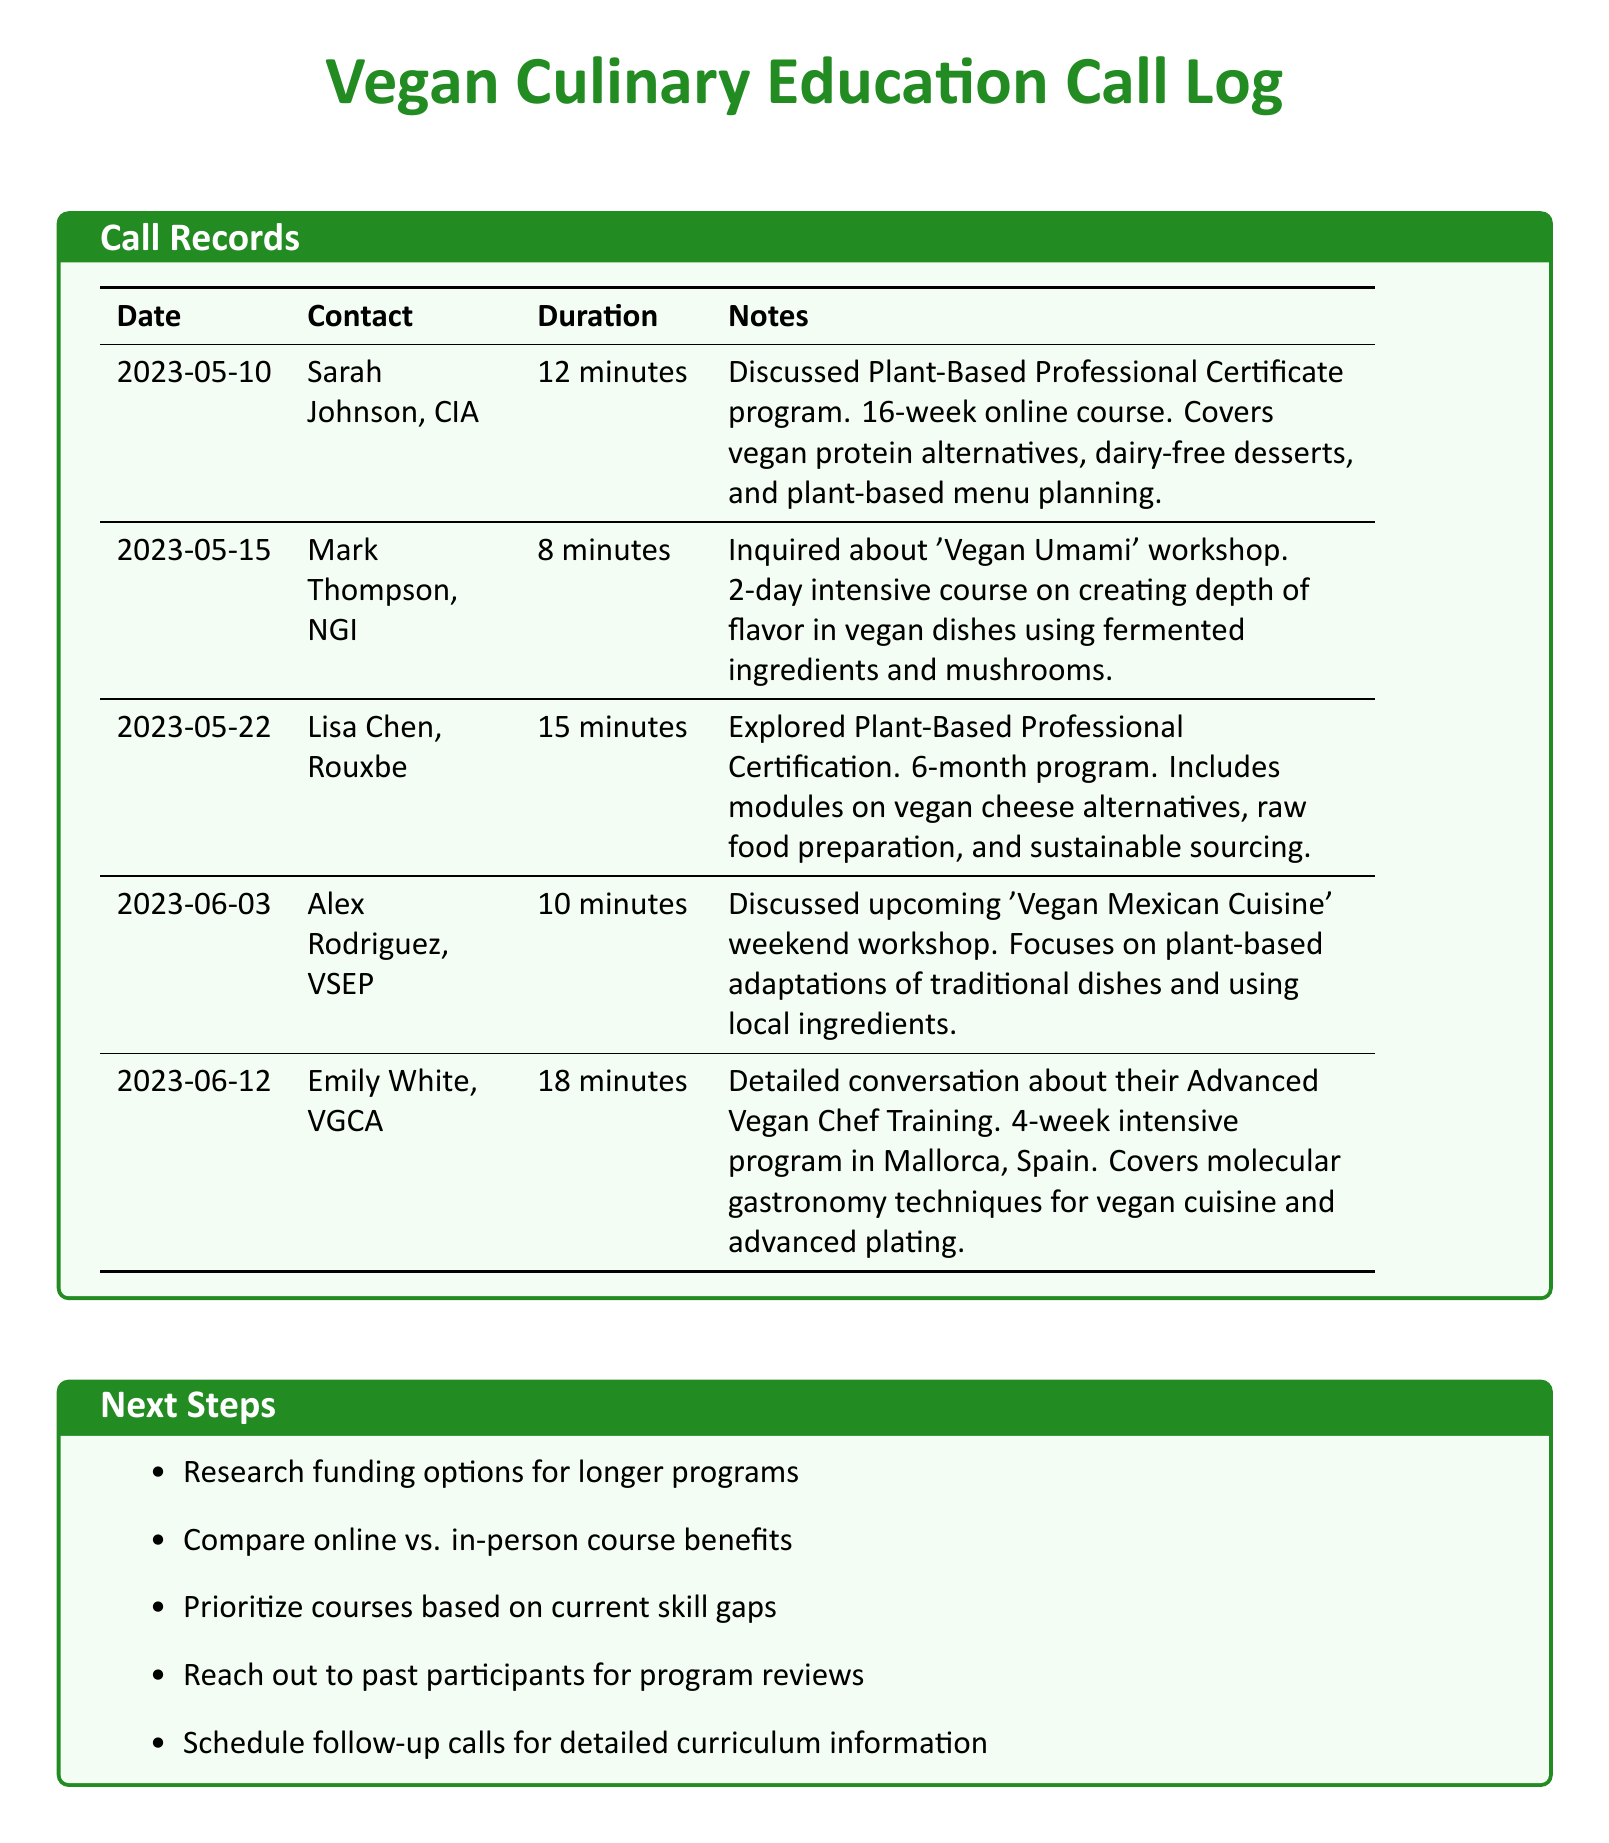What is the duration of the call with Sarah Johnson? The duration of the call with Sarah Johnson is noted in the call records as 12 minutes.
Answer: 12 minutes What is the main focus of the 'Vegan Mexican Cuisine' workshop? The main focus of the 'Vegan Mexican Cuisine' workshop is listed as plant-based adaptations of traditional dishes and using local ingredients.
Answer: Plant-based adaptations How long is the Plant-Based Professional Certificate program? The length of the Plant-Based Professional Certificate program, as mentioned in the document, is 16 weeks.
Answer: 16 weeks Who conducted the call regarding the 'Vegan Umami' workshop? The call regarding the 'Vegan Umami' workshop was conducted with Mark Thompson.
Answer: Mark Thompson Which program includes vegan cheese alternatives? The program that includes vegan cheese alternatives is the Plant-Based Professional Certification.
Answer: Plant-Based Professional Certification How many minutes did Emily White discuss the Advanced Vegan Chef Training? The total minutes of the call with Emily White is provided in the document as 18 minutes.
Answer: 18 minutes What is the location of the Advanced Vegan Chef Training? The location for the Advanced Vegan Chef Training, as specified, is Mallorca, Spain.
Answer: Mallorca, Spain What is the next step listed regarding funding options? The next step listed is to research funding options for longer programs.
Answer: Research funding options How many calls were made to discuss certification programs? The number of calls discussing certification programs is found by counting the relevant calls: 3.
Answer: 3 